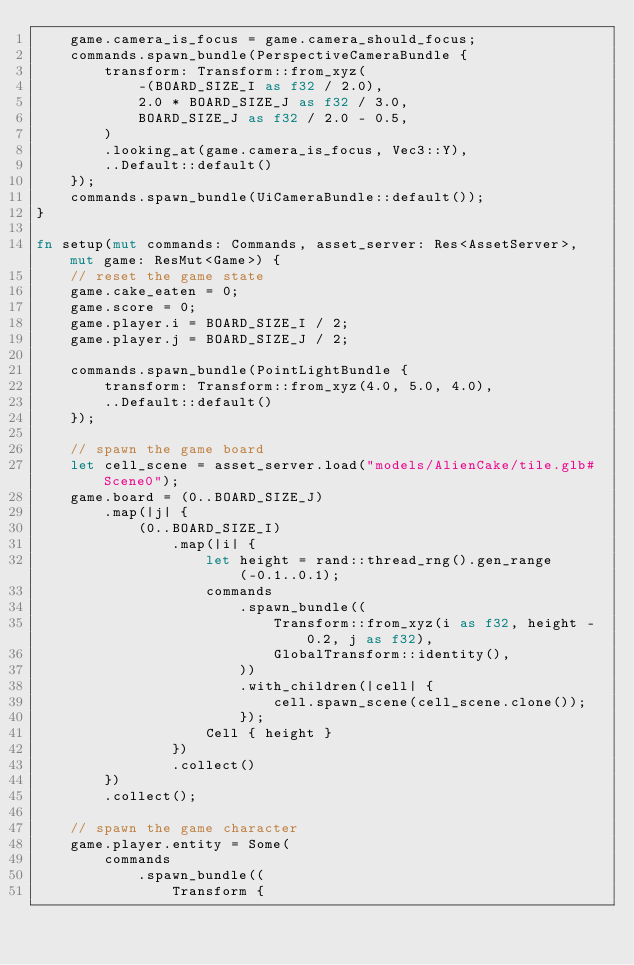Convert code to text. <code><loc_0><loc_0><loc_500><loc_500><_Rust_>    game.camera_is_focus = game.camera_should_focus;
    commands.spawn_bundle(PerspectiveCameraBundle {
        transform: Transform::from_xyz(
            -(BOARD_SIZE_I as f32 / 2.0),
            2.0 * BOARD_SIZE_J as f32 / 3.0,
            BOARD_SIZE_J as f32 / 2.0 - 0.5,
        )
        .looking_at(game.camera_is_focus, Vec3::Y),
        ..Default::default()
    });
    commands.spawn_bundle(UiCameraBundle::default());
}

fn setup(mut commands: Commands, asset_server: Res<AssetServer>, mut game: ResMut<Game>) {
    // reset the game state
    game.cake_eaten = 0;
    game.score = 0;
    game.player.i = BOARD_SIZE_I / 2;
    game.player.j = BOARD_SIZE_J / 2;

    commands.spawn_bundle(PointLightBundle {
        transform: Transform::from_xyz(4.0, 5.0, 4.0),
        ..Default::default()
    });

    // spawn the game board
    let cell_scene = asset_server.load("models/AlienCake/tile.glb#Scene0");
    game.board = (0..BOARD_SIZE_J)
        .map(|j| {
            (0..BOARD_SIZE_I)
                .map(|i| {
                    let height = rand::thread_rng().gen_range(-0.1..0.1);
                    commands
                        .spawn_bundle((
                            Transform::from_xyz(i as f32, height - 0.2, j as f32),
                            GlobalTransform::identity(),
                        ))
                        .with_children(|cell| {
                            cell.spawn_scene(cell_scene.clone());
                        });
                    Cell { height }
                })
                .collect()
        })
        .collect();

    // spawn the game character
    game.player.entity = Some(
        commands
            .spawn_bundle((
                Transform {</code> 